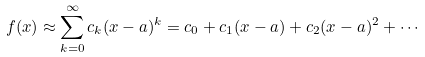Convert formula to latex. <formula><loc_0><loc_0><loc_500><loc_500>f ( x ) \approx \sum _ { k = 0 } ^ { \infty } c _ { k } ( x - a ) ^ { k } = c _ { 0 } + c _ { 1 } ( x - a ) + c _ { 2 } ( x - a ) ^ { 2 } + \cdots</formula> 